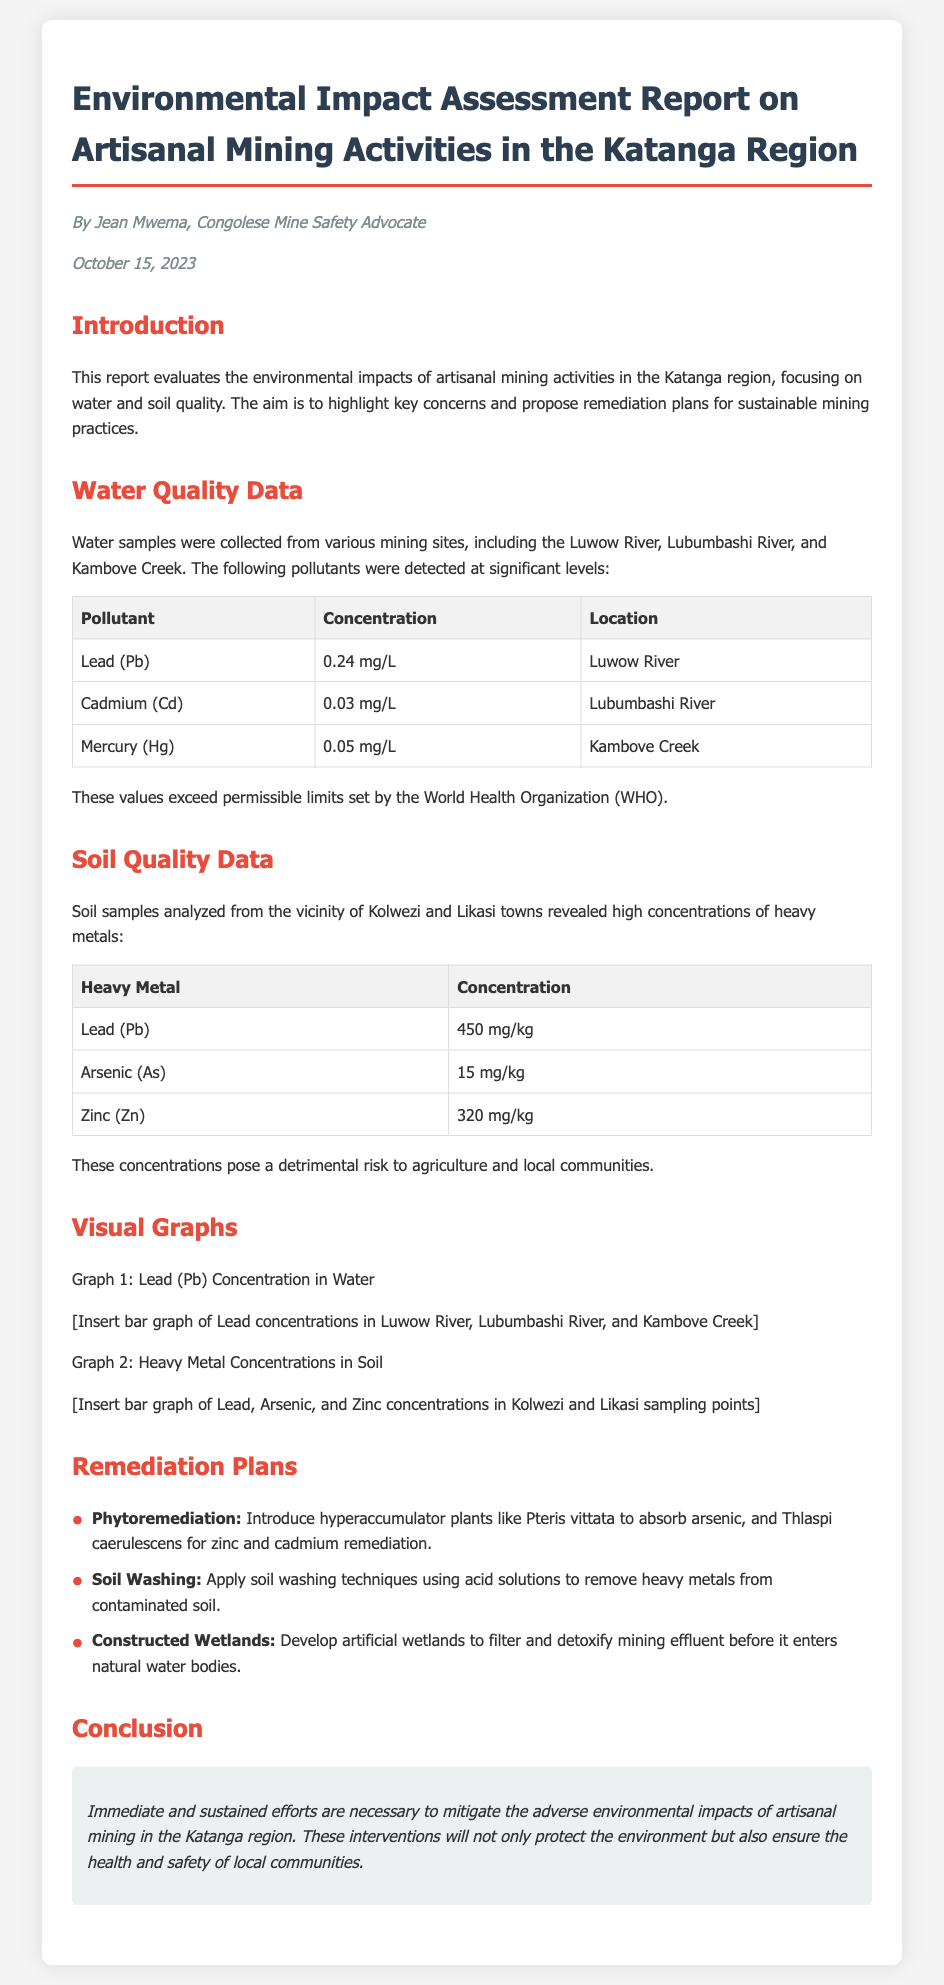what is the main focus of the report? The report evaluates the environmental impacts of artisanal mining activities, particularly on water and soil quality.
Answer: environmental impacts of artisanal mining activities who authored the report? The author of the report is mentioned in the document.
Answer: Jean Mwema what is the concentration of Lead in the Luwow River? The concentration listed for Lead in the Luwow River is specified in the water quality data section.
Answer: 0.24 mg/L which heavy metal has the highest concentration in soil from Kolwezi? The soil quality data provides details about heavy metal concentrations, listing the highest.
Answer: Lead (Pb) what remediation technique involves using plants? The remediation plans section details various strategies, one of which uses plants.
Answer: Phytoremediation what is the concentration of Arsenic in the soil? The specific concentration for Arsenic is noted in the soil quality data.
Answer: 15 mg/kg how many remediation techniques are proposed in the report? The report outlines several techniques in the remediation plans section.
Answer: 3 which water body had a Cadmium concentration detected? The report lists locations for water quality data, including one with Cadmium.
Answer: Lubumbashi River 